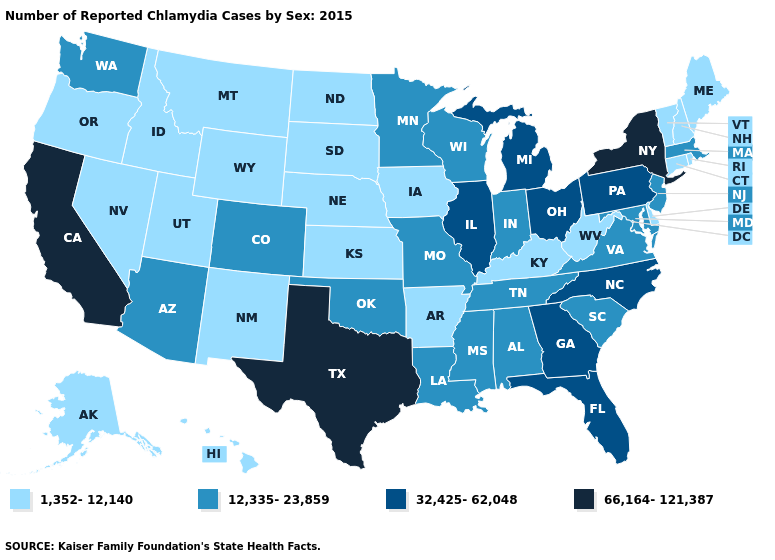What is the lowest value in the USA?
Give a very brief answer. 1,352-12,140. Does Montana have the lowest value in the West?
Concise answer only. Yes. What is the value of Utah?
Short answer required. 1,352-12,140. What is the lowest value in the South?
Keep it brief. 1,352-12,140. Among the states that border Tennessee , which have the lowest value?
Quick response, please. Arkansas, Kentucky. What is the value of New Mexico?
Be succinct. 1,352-12,140. Name the states that have a value in the range 32,425-62,048?
Answer briefly. Florida, Georgia, Illinois, Michigan, North Carolina, Ohio, Pennsylvania. Does New York have the highest value in the USA?
Be succinct. Yes. Name the states that have a value in the range 12,335-23,859?
Be succinct. Alabama, Arizona, Colorado, Indiana, Louisiana, Maryland, Massachusetts, Minnesota, Mississippi, Missouri, New Jersey, Oklahoma, South Carolina, Tennessee, Virginia, Washington, Wisconsin. Name the states that have a value in the range 32,425-62,048?
Keep it brief. Florida, Georgia, Illinois, Michigan, North Carolina, Ohio, Pennsylvania. Name the states that have a value in the range 66,164-121,387?
Quick response, please. California, New York, Texas. What is the value of South Carolina?
Quick response, please. 12,335-23,859. What is the highest value in states that border Vermont?
Quick response, please. 66,164-121,387. Does New York have the same value as Utah?
Quick response, please. No. What is the value of Nebraska?
Quick response, please. 1,352-12,140. 